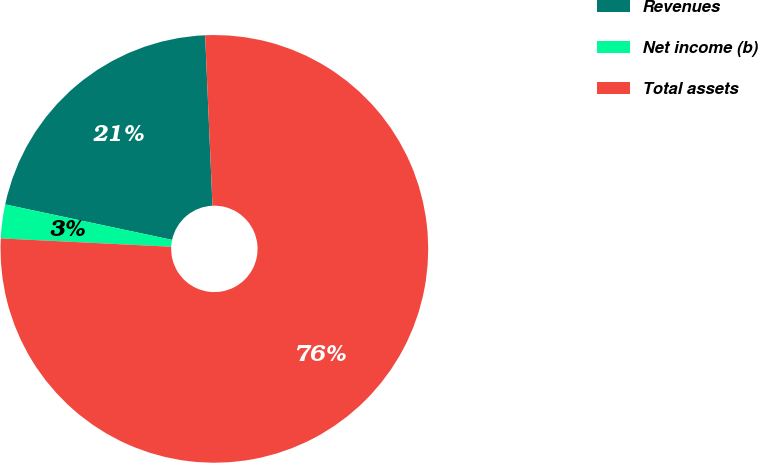<chart> <loc_0><loc_0><loc_500><loc_500><pie_chart><fcel>Revenues<fcel>Net income (b)<fcel>Total assets<nl><fcel>20.98%<fcel>2.55%<fcel>76.47%<nl></chart> 